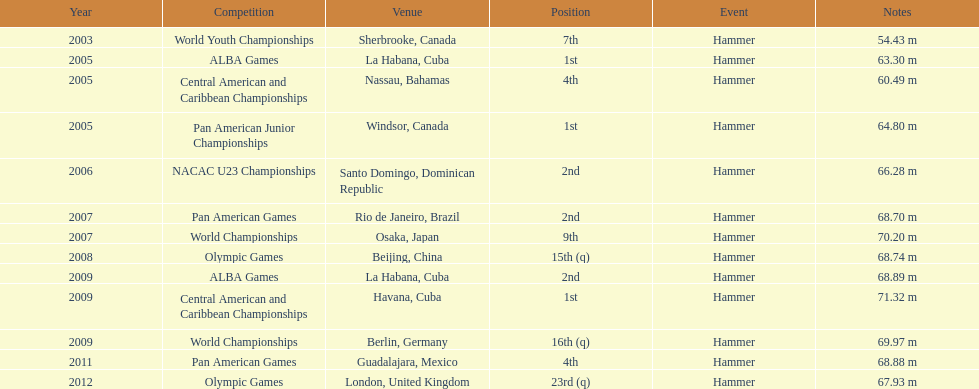In which olympics did arasay thondike not rank in the first 20 positions? 2012. 